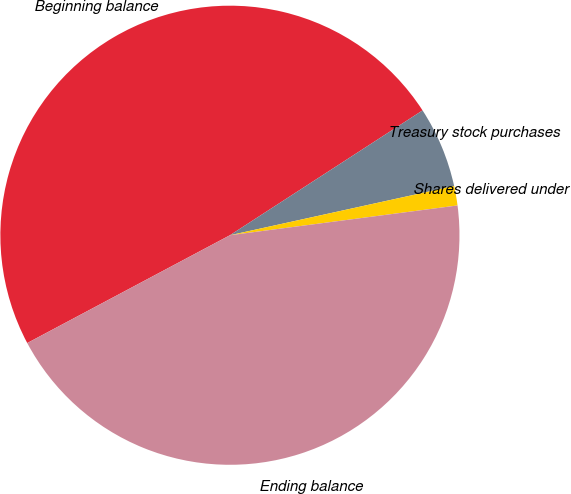Convert chart to OTSL. <chart><loc_0><loc_0><loc_500><loc_500><pie_chart><fcel>Beginning balance<fcel>Treasury stock purchases<fcel>Shares delivered under<fcel>Ending balance<nl><fcel>48.63%<fcel>5.71%<fcel>1.37%<fcel>44.29%<nl></chart> 